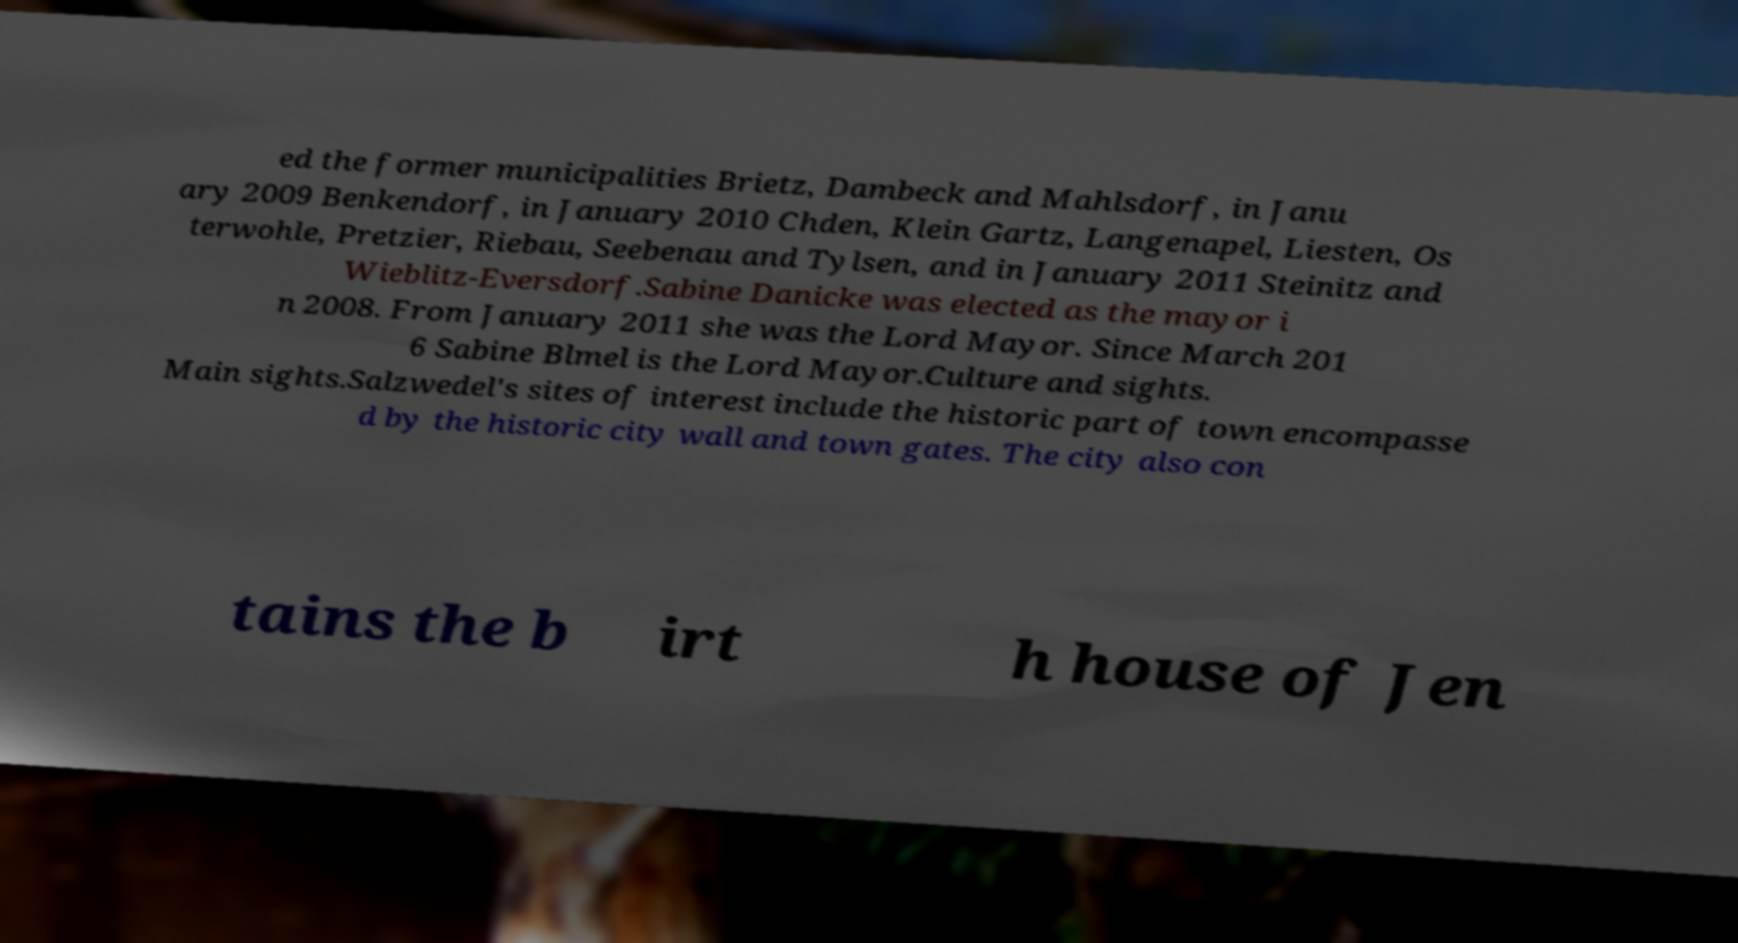Can you read and provide the text displayed in the image?This photo seems to have some interesting text. Can you extract and type it out for me? ed the former municipalities Brietz, Dambeck and Mahlsdorf, in Janu ary 2009 Benkendorf, in January 2010 Chden, Klein Gartz, Langenapel, Liesten, Os terwohle, Pretzier, Riebau, Seebenau and Tylsen, and in January 2011 Steinitz and Wieblitz-Eversdorf.Sabine Danicke was elected as the mayor i n 2008. From January 2011 she was the Lord Mayor. Since March 201 6 Sabine Blmel is the Lord Mayor.Culture and sights. Main sights.Salzwedel's sites of interest include the historic part of town encompasse d by the historic city wall and town gates. The city also con tains the b irt h house of Jen 